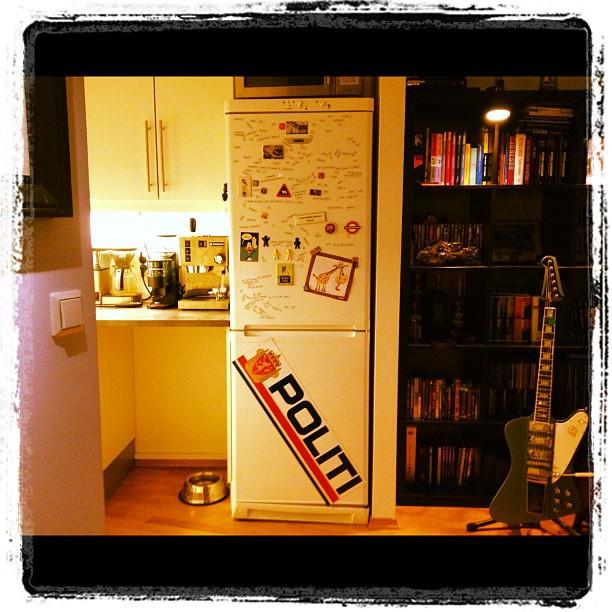What is the style of the guitar?
Be succinct. Electric. What color is the photo?
Short answer required. Yellow. Are there any books on the shelves?
Quick response, please. Yes. Where is a pets bowl?
Short answer required. Kitchen. 